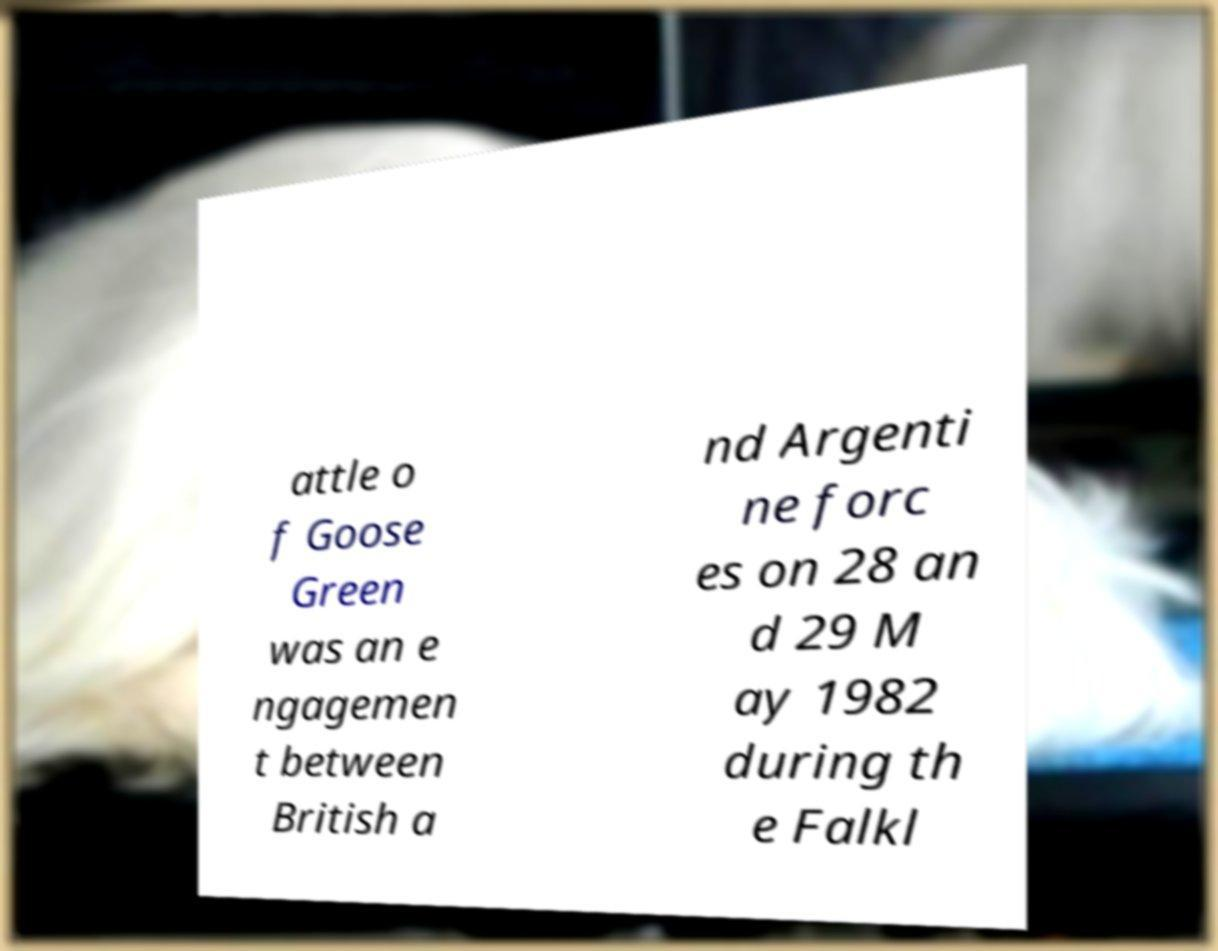Please identify and transcribe the text found in this image. attle o f Goose Green was an e ngagemen t between British a nd Argenti ne forc es on 28 an d 29 M ay 1982 during th e Falkl 